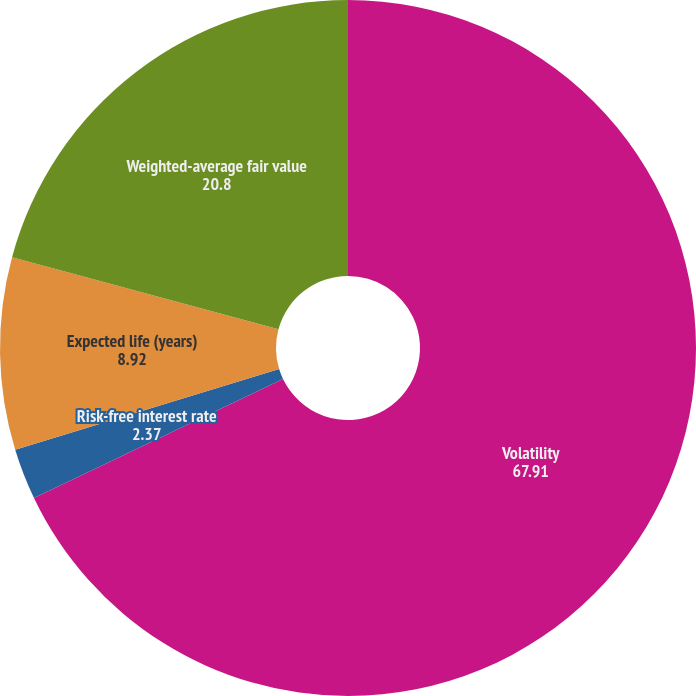Convert chart to OTSL. <chart><loc_0><loc_0><loc_500><loc_500><pie_chart><fcel>Volatility<fcel>Risk-free interest rate<fcel>Expected life (years)<fcel>Weighted-average fair value<nl><fcel>67.91%<fcel>2.37%<fcel>8.92%<fcel>20.8%<nl></chart> 